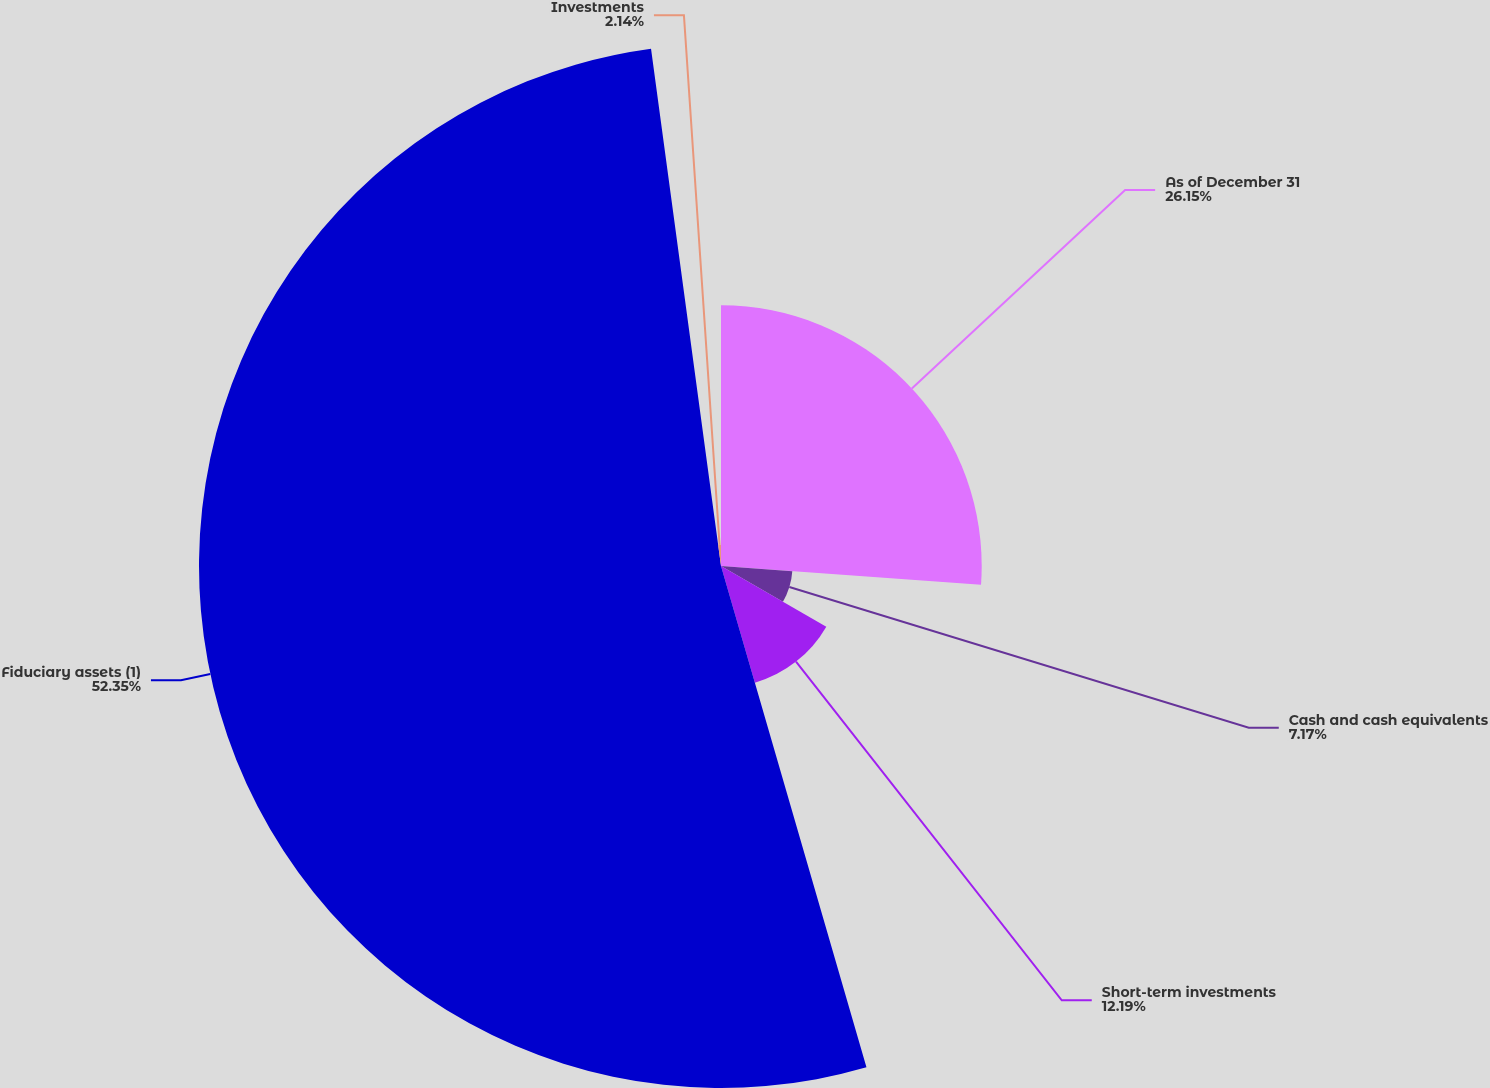Convert chart to OTSL. <chart><loc_0><loc_0><loc_500><loc_500><pie_chart><fcel>As of December 31<fcel>Cash and cash equivalents<fcel>Short-term investments<fcel>Fiduciary assets (1)<fcel>Investments<nl><fcel>26.15%<fcel>7.17%<fcel>12.19%<fcel>52.36%<fcel>2.14%<nl></chart> 